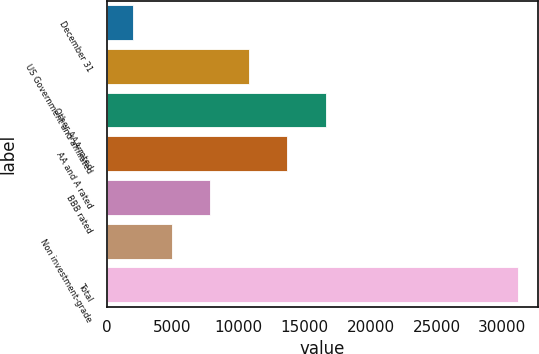<chart> <loc_0><loc_0><loc_500><loc_500><bar_chart><fcel>December 31<fcel>US Government and affiliated<fcel>Other AAA rated<fcel>AA and A rated<fcel>BBB rated<fcel>Non investment-grade<fcel>Total<nl><fcel>2004<fcel>10755.9<fcel>16590.5<fcel>13673.2<fcel>7838.6<fcel>4921.3<fcel>31177<nl></chart> 